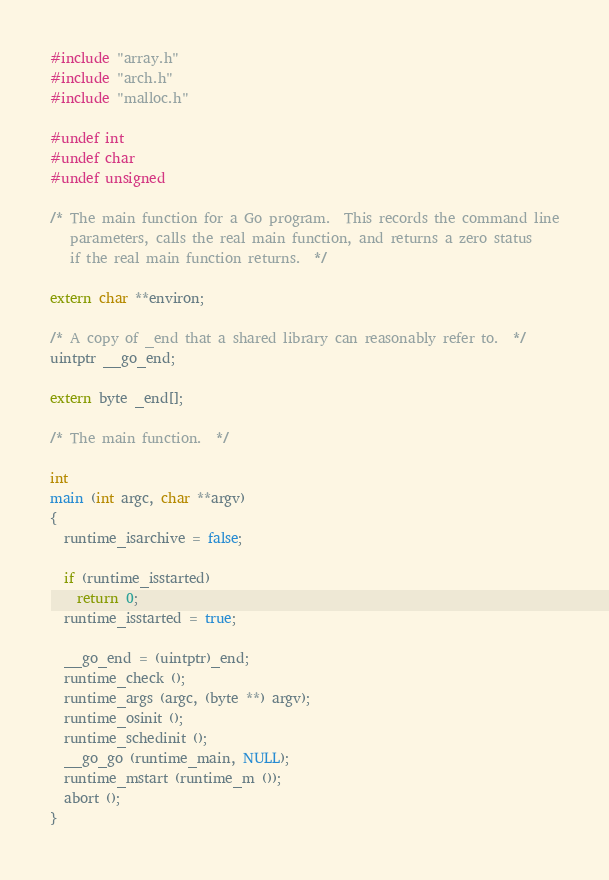<code> <loc_0><loc_0><loc_500><loc_500><_C_>#include "array.h"
#include "arch.h"
#include "malloc.h"

#undef int
#undef char
#undef unsigned

/* The main function for a Go program.  This records the command line
   parameters, calls the real main function, and returns a zero status
   if the real main function returns.  */

extern char **environ;

/* A copy of _end that a shared library can reasonably refer to.  */
uintptr __go_end;

extern byte _end[];

/* The main function.  */

int
main (int argc, char **argv)
{
  runtime_isarchive = false;

  if (runtime_isstarted)
    return 0;
  runtime_isstarted = true;

  __go_end = (uintptr)_end;
  runtime_check ();
  runtime_args (argc, (byte **) argv);
  runtime_osinit ();
  runtime_schedinit ();
  __go_go (runtime_main, NULL);
  runtime_mstart (runtime_m ());
  abort ();
}
</code> 